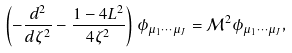<formula> <loc_0><loc_0><loc_500><loc_500>\left ( - \frac { d ^ { 2 } } { d \zeta ^ { 2 } } - \frac { 1 - 4 L ^ { 2 } } { 4 \zeta ^ { 2 } } \right ) \phi _ { \mu _ { 1 } \cdots \mu _ { J } } = \mathcal { M } ^ { 2 } \phi _ { \mu _ { 1 } \cdots \mu _ { J } } ,</formula> 